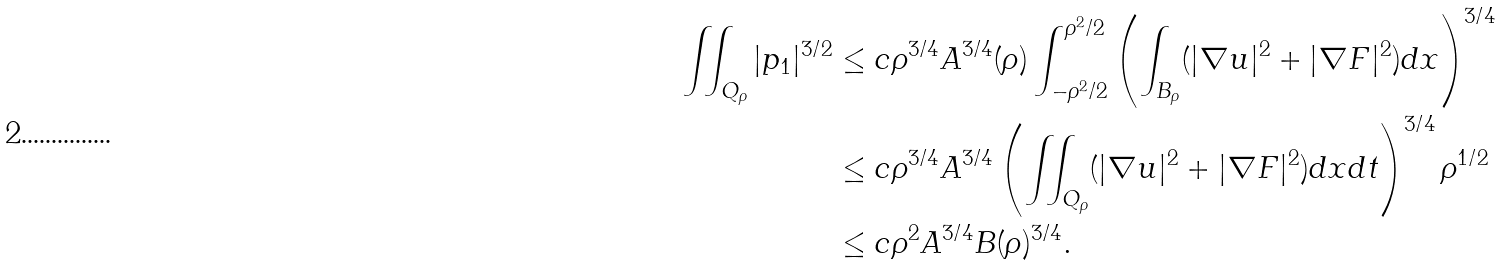<formula> <loc_0><loc_0><loc_500><loc_500>\iint _ { Q _ { \rho } } | p _ { 1 } | ^ { 3 / 2 } & \leq c \rho ^ { 3 / 4 } A ^ { 3 / 4 } ( \rho ) \int ^ { \rho ^ { 2 } / 2 } _ { - \rho ^ { 2 } / 2 } \left ( \int _ { B _ { \rho } } ( | \nabla u | ^ { 2 } + | \nabla F | ^ { 2 } ) d x \right ) ^ { 3 / 4 } \\ & \leq c \rho ^ { 3 / 4 } A ^ { 3 / 4 } \left ( \iint _ { Q _ { \rho } } ( | \nabla u | ^ { 2 } + | \nabla F | ^ { 2 } ) d x d t \right ) ^ { 3 / 4 } \rho ^ { 1 / 2 } \\ & \leq c \rho ^ { 2 } A ^ { 3 / 4 } B ( \rho ) ^ { 3 / 4 } .</formula> 